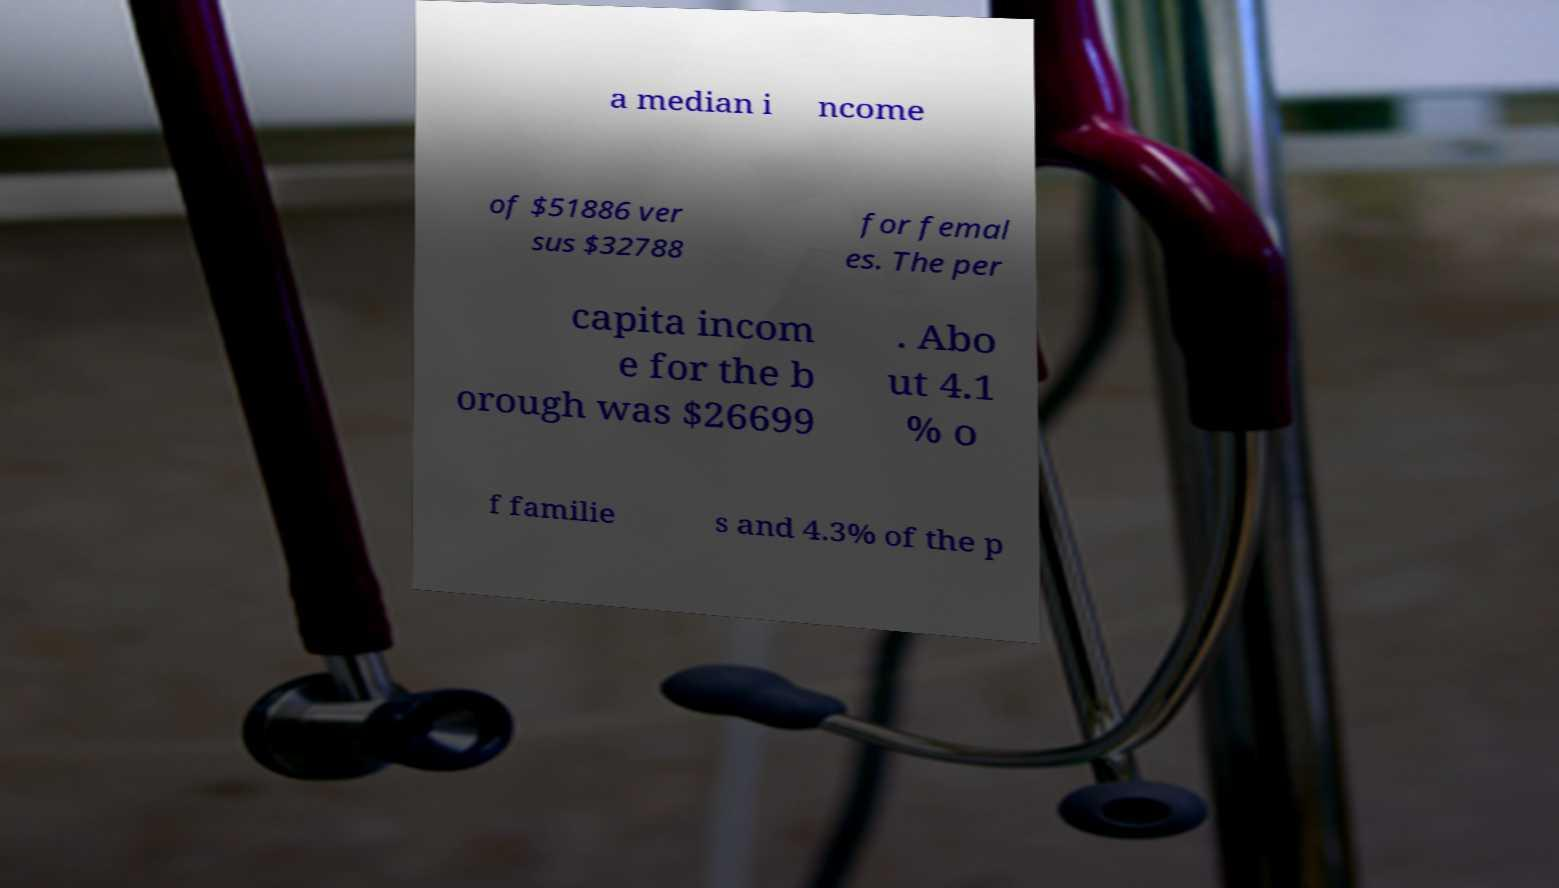What messages or text are displayed in this image? I need them in a readable, typed format. a median i ncome of $51886 ver sus $32788 for femal es. The per capita incom e for the b orough was $26699 . Abo ut 4.1 % o f familie s and 4.3% of the p 